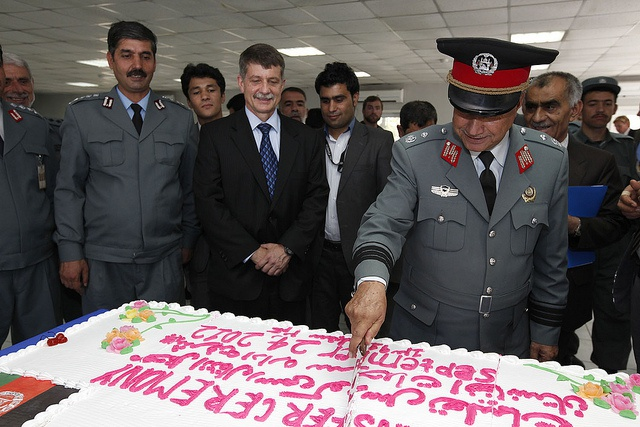Describe the objects in this image and their specific colors. I can see cake in gray, white, violet, lightpink, and brown tones, people in gray, black, and maroon tones, people in gray and black tones, people in gray, black, and maroon tones, and people in gray, black, and maroon tones in this image. 